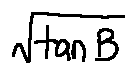<formula> <loc_0><loc_0><loc_500><loc_500>\sqrt { \tan B }</formula> 